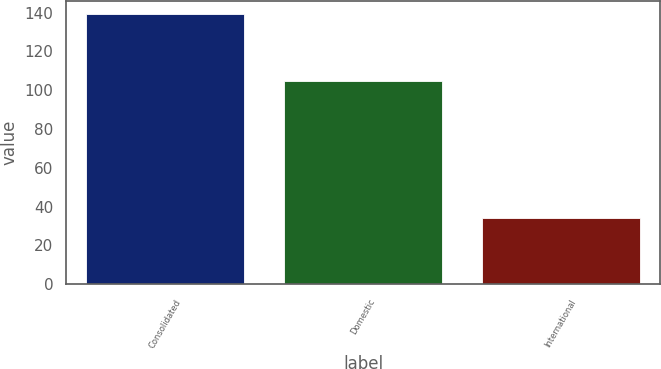Convert chart to OTSL. <chart><loc_0><loc_0><loc_500><loc_500><bar_chart><fcel>Consolidated<fcel>Domestic<fcel>International<nl><fcel>139.1<fcel>104.8<fcel>34.3<nl></chart> 